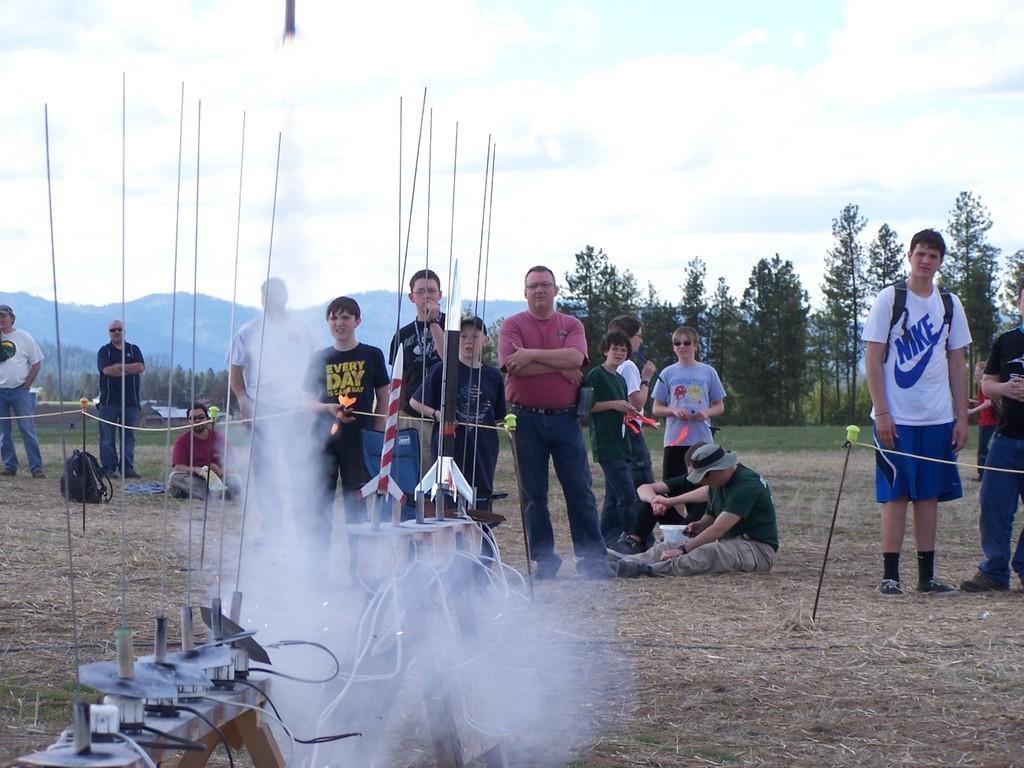Could you give a brief overview of what you see in this image? This picture describes about group of people, few are standing and few are seated on the ground, in front of them we can see few metal rods and cables, in the background we can find few trees, hills and houses. 